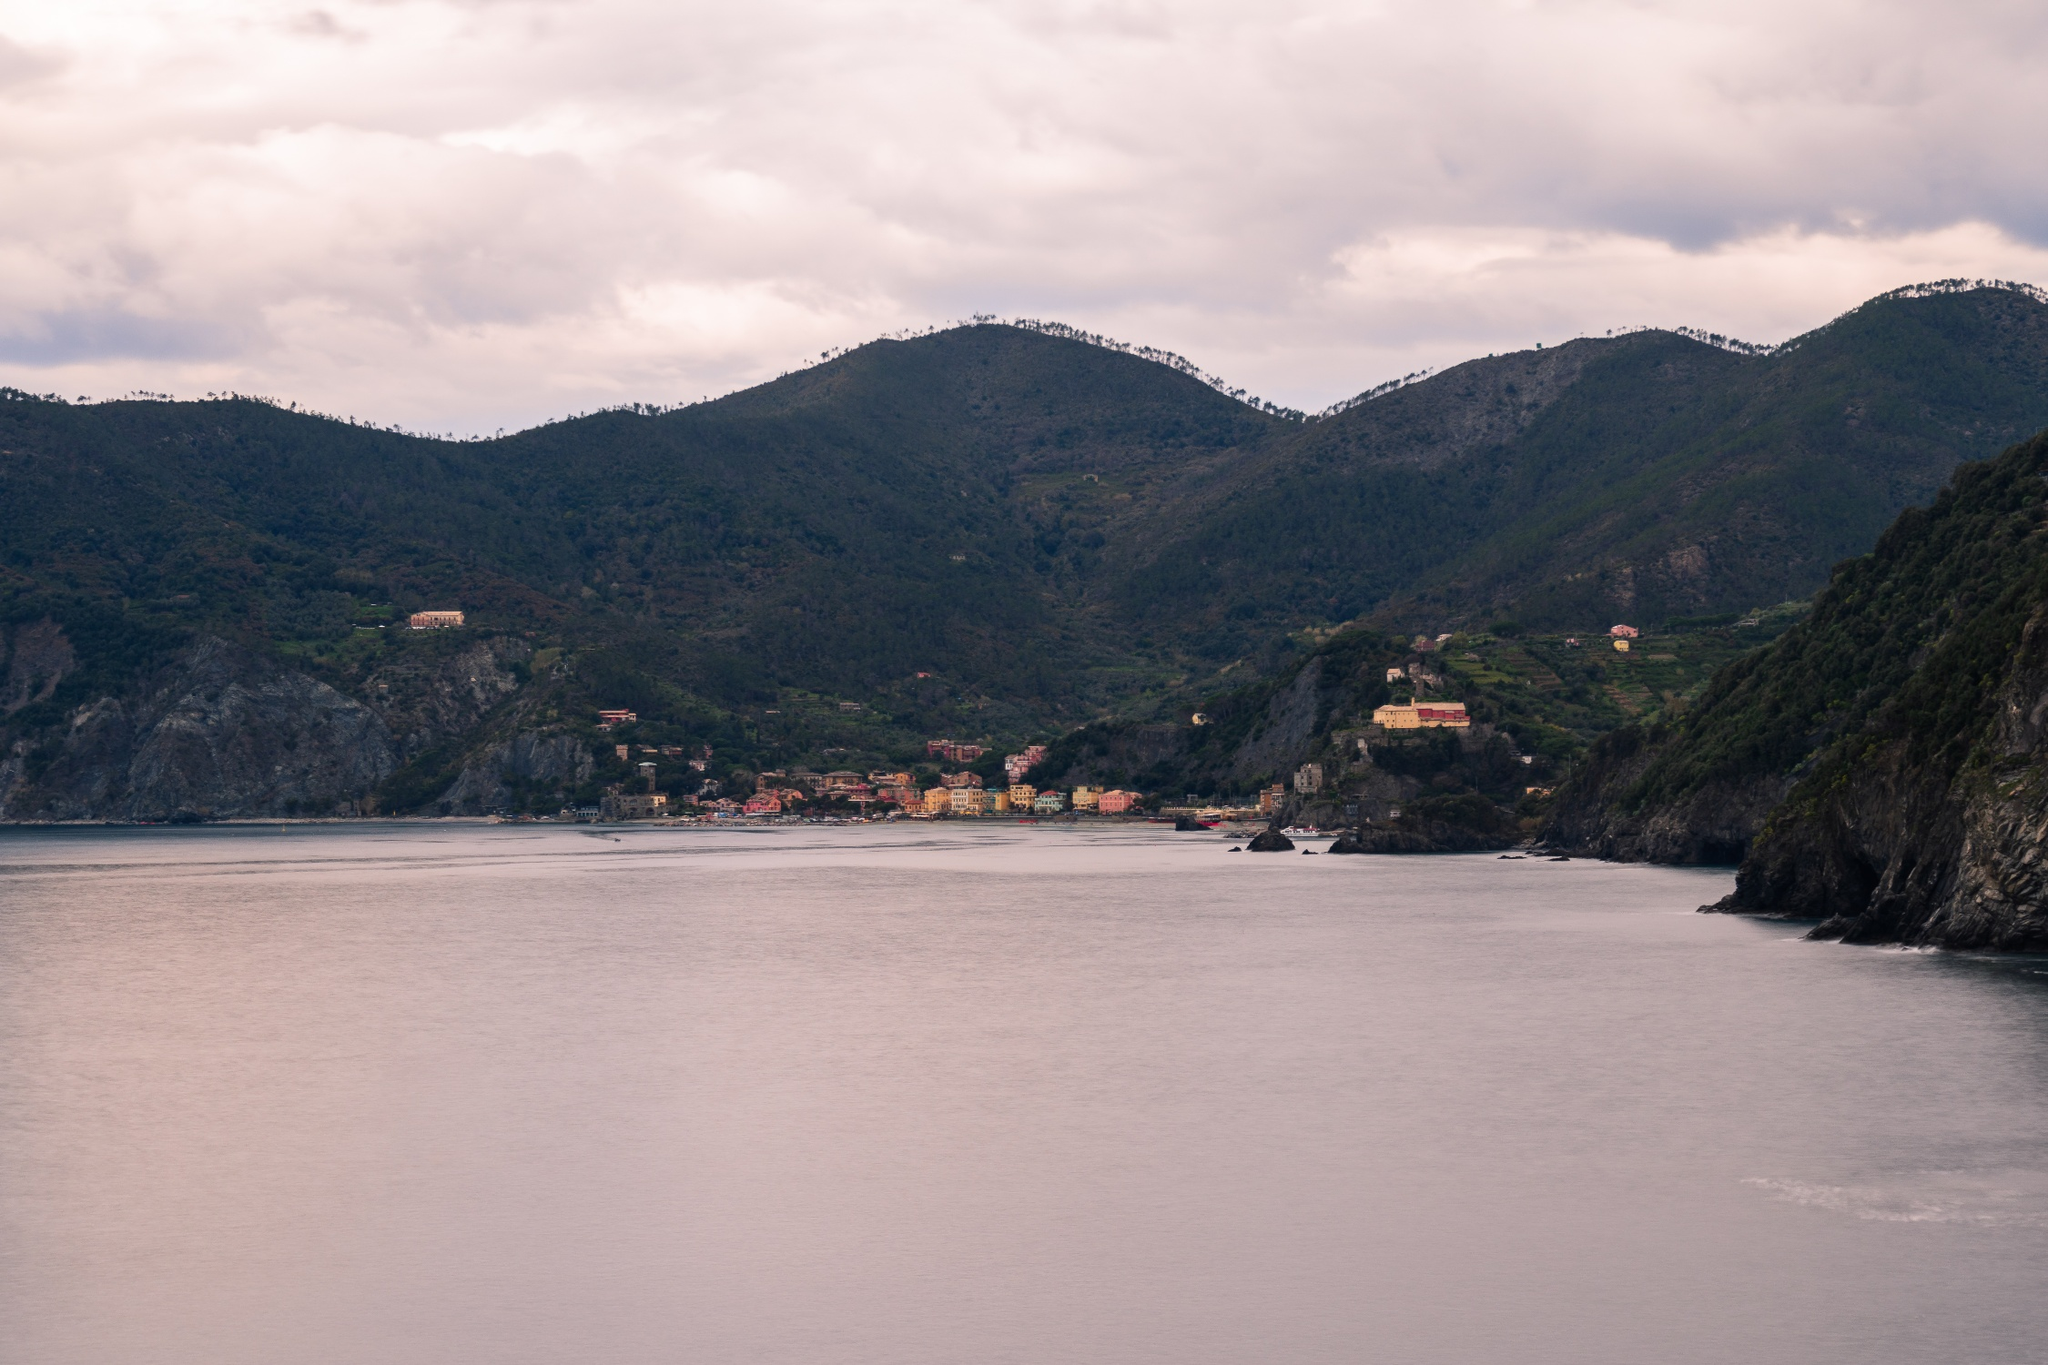Describe the natural elements seen in the image. The image showcases a stunning combination of natural elements. In the foreground, the calm sea lies still, reflecting the soft light of the overcast sky. Surrounding the coastal town, lush green hills provide a vivid contrast to the buildings' colorful facades. These hills are interspersed with rugged cliffs that add a dramatic touch to the landscape. Beyond the hills, the scene is framed by the soft outlines of larger mountains in the background, shrouded partially by clouds. 